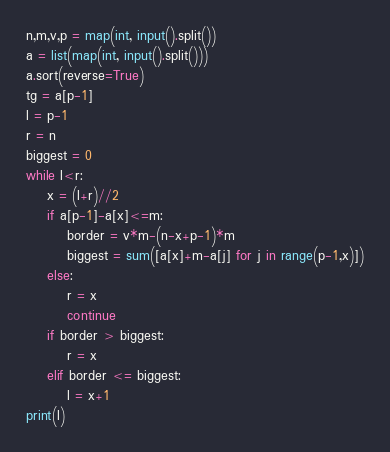Convert code to text. <code><loc_0><loc_0><loc_500><loc_500><_Python_>n,m,v,p = map(int, input().split())
a = list(map(int, input().split()))
a.sort(reverse=True)
tg = a[p-1]
l = p-1
r = n
biggest = 0
while l<r:
    x = (l+r)//2
    if a[p-1]-a[x]<=m:
        border = v*m-(n-x+p-1)*m
        biggest = sum([a[x]+m-a[j] for j in range(p-1,x)])
    else:
        r = x
        continue
    if border > biggest:
        r = x
    elif border <= biggest:
        l = x+1
print(l)</code> 